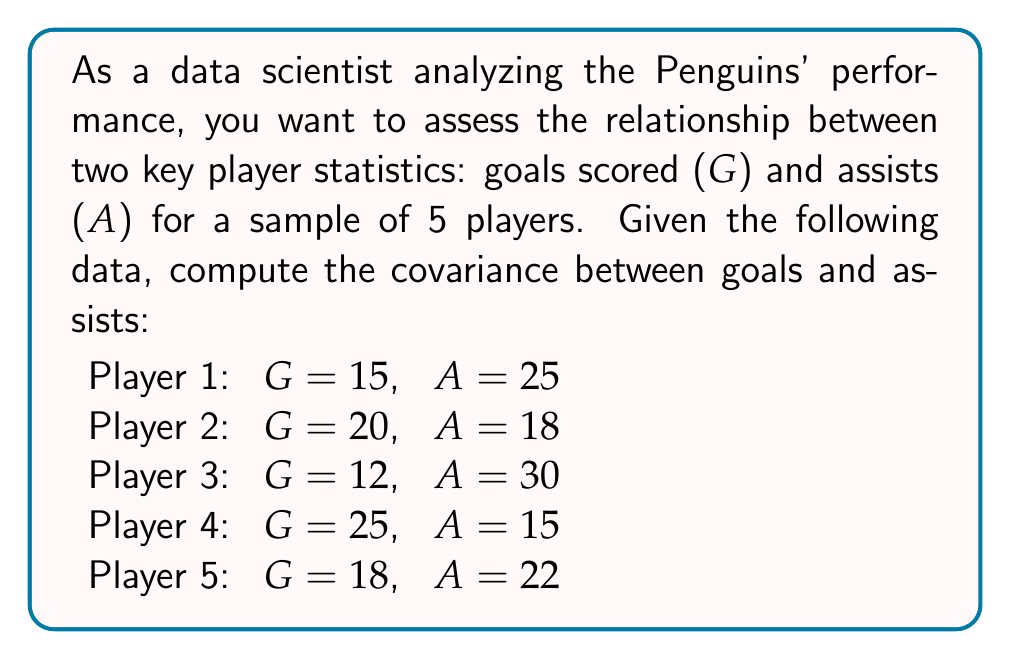Help me with this question. To compute the covariance between goals (G) and assists (A), we'll follow these steps:

1. Calculate the means of G and A:
   $$\bar{G} = \frac{15 + 20 + 12 + 25 + 18}{5} = 18$$
   $$\bar{A} = \frac{25 + 18 + 30 + 15 + 22}{5} = 22$$

2. Calculate $(G_i - \bar{G})$ and $(A_i - \bar{A})$ for each player:
   Player 1: $15 - 18 = -3$, $25 - 22 = 3$
   Player 2: $20 - 18 = 2$, $18 - 22 = -4$
   Player 3: $12 - 18 = -6$, $30 - 22 = 8$
   Player 4: $25 - 18 = 7$, $15 - 22 = -7$
   Player 5: $18 - 18 = 0$, $22 - 22 = 0$

3. Multiply $(G_i - \bar{G})$ and $(A_i - \bar{A})$ for each player:
   Player 1: $(-3)(3) = -9$
   Player 2: $(2)(-4) = -8$
   Player 3: $(-6)(8) = -48$
   Player 4: $(7)(-7) = -49$
   Player 5: $(0)(0) = 0$

4. Sum the products:
   $$\sum_{i=1}^{5} (G_i - \bar{G})(A_i - \bar{A}) = -9 + (-8) + (-48) + (-49) + 0 = -114$$

5. Divide by (n-1) to get the sample covariance:
   $$Cov(G,A) = \frac{1}{n-1} \sum_{i=1}^{n} (G_i - \bar{G})(A_i - \bar{A}) = \frac{-114}{4} = -28.5$$

The negative covariance indicates an inverse relationship between goals and assists for this sample of players.
Answer: $$Cov(G,A) = -28.5$$ 